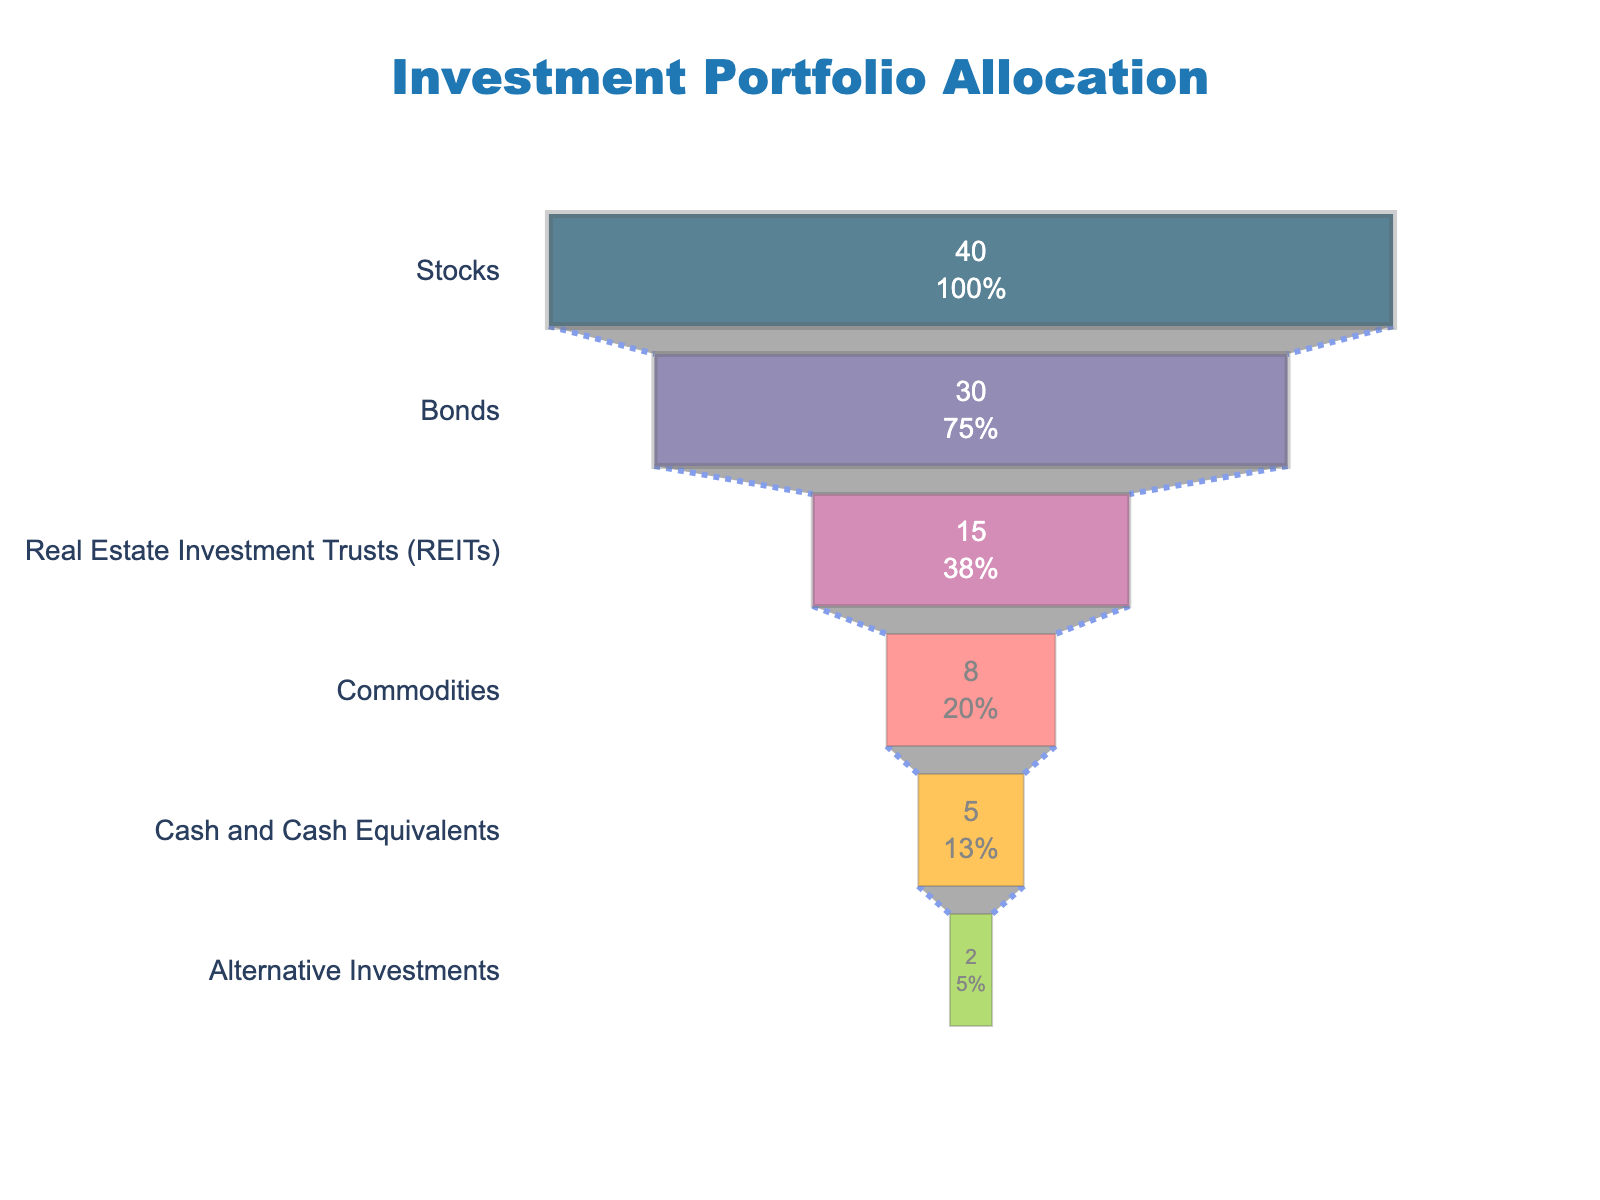What is the title of the funnel chart? The title of the funnel chart is displayed prominently at the top of the figure. It reads "Investment Portfolio Allocation."
Answer: Investment Portfolio Allocation How many asset classes are represented in the funnel chart? By counting the different segments in the funnel chart, we see that the total number of asset classes being represented is six.
Answer: Six Which asset class has the highest allocation percentage? From the funnel chart, the section with the largest width at the top represents the asset class with the highest allocation percentage, which is "Stocks" at 40%.
Answer: Stocks What is the total allocation percentage for Bonds and REITs combined? The allocation percentages for Bonds and REITs are 30% and 15%, respectively. By summing these values, we get 30% + 15% = 45%.
Answer: 45% How much more is allocated to Stocks compared to Commodities? The allocation percentages for Stocks and Commodities are 40% and 8%, respectively. Subtracting these values, we find 40% - 8% = 32%.
Answer: 32% Do Cash and Cash Equivalents have a higher allocation percentage than Alternative Investments? From the funnel chart, the allocation percentage for Cash and Cash Equivalents is 5%, while for Alternative Investments, it is 2%. Since 5% is greater than 2%, Cash and Cash Equivalents have a higher allocation percentage than Alternative Investments.
Answer: Yes What is the combined allocation percentage of the smallest two asset classes? The smallest two asset classes in terms of allocation percentages are Alternative Investments (2%) and Cash and Cash Equivalents (5%). Summing these values, we get 2% + 5% = 7%.
Answer: 7% Estimate the average allocation percentage across all asset classes. The allocation percentages for all asset classes are as follows: 40%, 30%, 15%, 8%, 5%, and 2%. Adding these together yields a total of 100%. There are six asset classes, so the average allocation percentage is 100% / 6 ≈ 16.67%.
Answer: 16.67% Which asset class is third in terms of allocation? The funnel chart sorts asset classes by allocation percentage in descending order. The third section from the top represents the third largest allocation, which is "Real Estate Investment Trusts (REITs)" at 15%.
Answer: Real Estate Investment Trusts (REITs) 